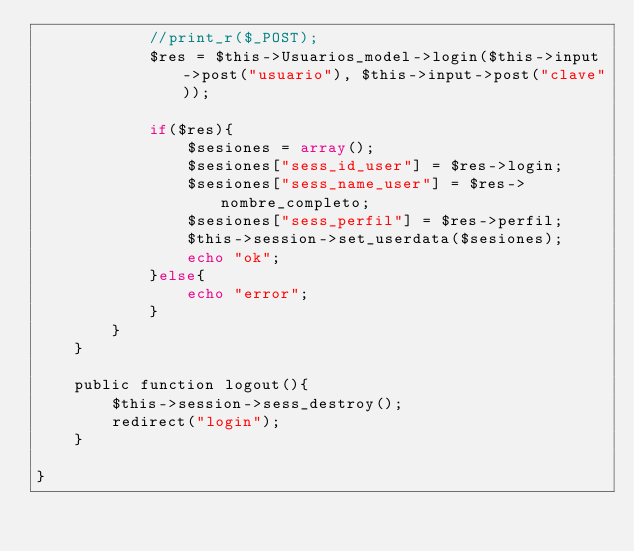Convert code to text. <code><loc_0><loc_0><loc_500><loc_500><_PHP_>			//print_r($_POST);
			$res = $this->Usuarios_model->login($this->input->post("usuario"), $this->input->post("clave"));
			
			if($res){
				$sesiones = array();
				$sesiones["sess_id_user"] = $res->login;
				$sesiones["sess_name_user"] = $res->nombre_completo;
				$sesiones["sess_perfil"] = $res->perfil;
				$this->session->set_userdata($sesiones);
				echo "ok";
			}else{
				echo "error";
			}
		}
	}

	public function logout(){
		$this->session->sess_destroy();
		redirect("login");
	}

}</code> 